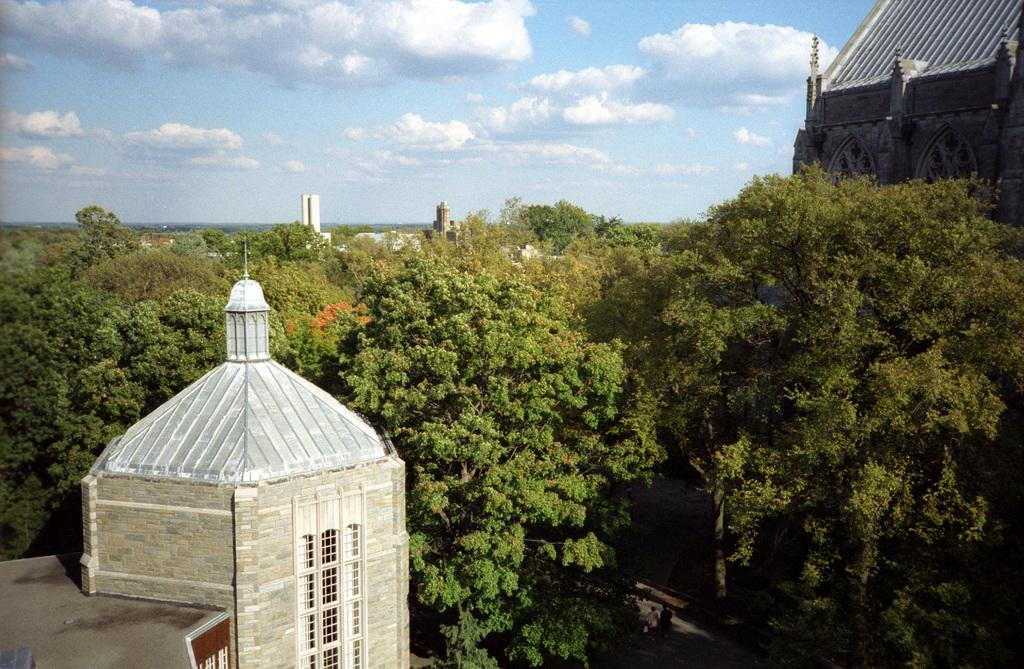How many buildings can be seen in the image? There are two buildings in the image. What is present between the two buildings? There are a lot of trees between the buildings. What is the price of the trees between the buildings? There is no price associated with the trees in the image, as they are not for sale. 